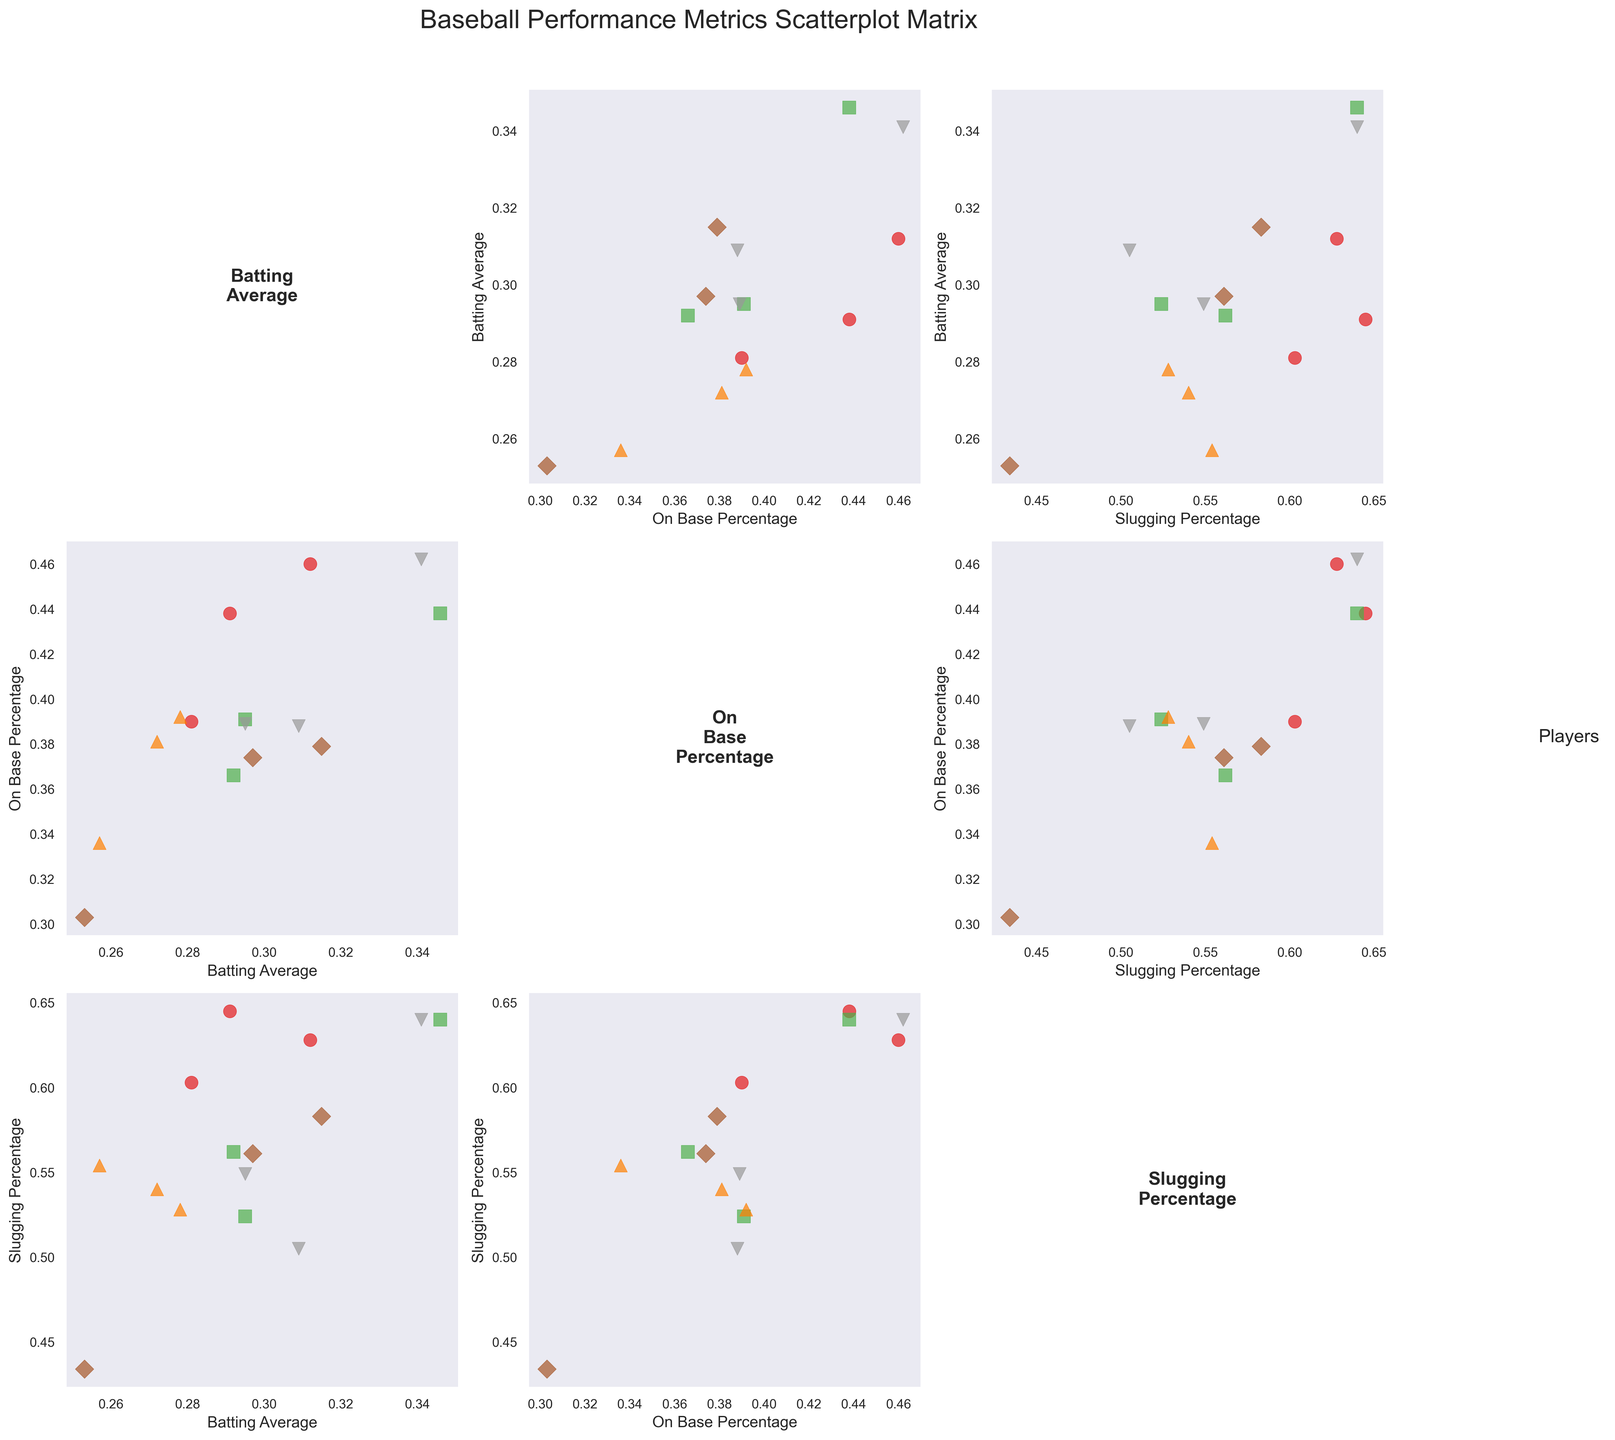Which player has the highest batting average in any given season? To determine this, look at the scatterplots involving Batting Average on the y-axis and identify the highest point. Mike Trout in 2018 and Freddie Freeman in 2020 both have the highest batting average with 0.346 and 0.341 respectively.
Answer: Mike Trout (2018) and Freddie Freeman (2020) What is the trend in Aaron Judge's on-base percentage over the three seasons? Identify the scatterplot with On_Base_Percentage on the y-axis and plot the points for Aaron Judge in each season. Aaron Judge's on-base percentage decreases over the seasons from 0.392 in 2018 to 0.336 in 2020.
Answer: Decreasing Which two players have the most similar batting averages in the 2019 season? Compare the Batting_Average scatterplots for 2019 and look for the closest points. Mookie Betts and Freddie Freeman both have similar batting averages in 2019 around 0.295.
Answer: Mookie Betts and Freddie Freeman Is there a player whose slugging percentage and on-base percentage are almost equal in any season? Examine the scatterplots where Slugging_Percentage and On_Base_Percentage are on the axes, looking for points near the diagonal line. No player has almost equal percentages in the given data.
Answer: No Considering Mike Trout, does a higher batting average correspond to a higher slugging percentage based on the data? Look for Mike Trout's points in the scatterplot of Batting Average vs. Slugging Percentage. Higher batting averages for Mike Trout generally correspond to higher slugging percentages.
Answer: Yes Who had the highest slugging percentage in the 2020 season? Check the scatterplot involving Slugging Percentage and identify the highest point for 2020. Freddie Freeman has the highest slugging percentage in 2020 with 0.640.
Answer: Freddie Freeman Did any player's performance metrics consistently decrease from 2018 to 2020? Examine the scatterplots for all metrics (Batting Average, On Base Percentage, Slugging Percentage) over the three seasons for each player. Nolan Arenado's metrics consistently decreased across all three categories from 2018 to 2020.
Answer: Nolan Arenado How does Freddie Freeman's on-base percentage in 2019 compare with his batting average in the same year? Find Freddie Freeman's points in the scatterplot of On_Base_Percentage vs. Batting_Average for 2019. His on-base percentage was slightly higher than his batting average in 2019 (0.389 vs. 0.295).
Answer: Higher Is there a strong correlation between batting average and slugging percentage across all players? Look at the scatterplot of Batting Average vs. Slugging Percentage to see if the points tend to form a line. Generally, there is a positive correlation.
Answer: Yes 